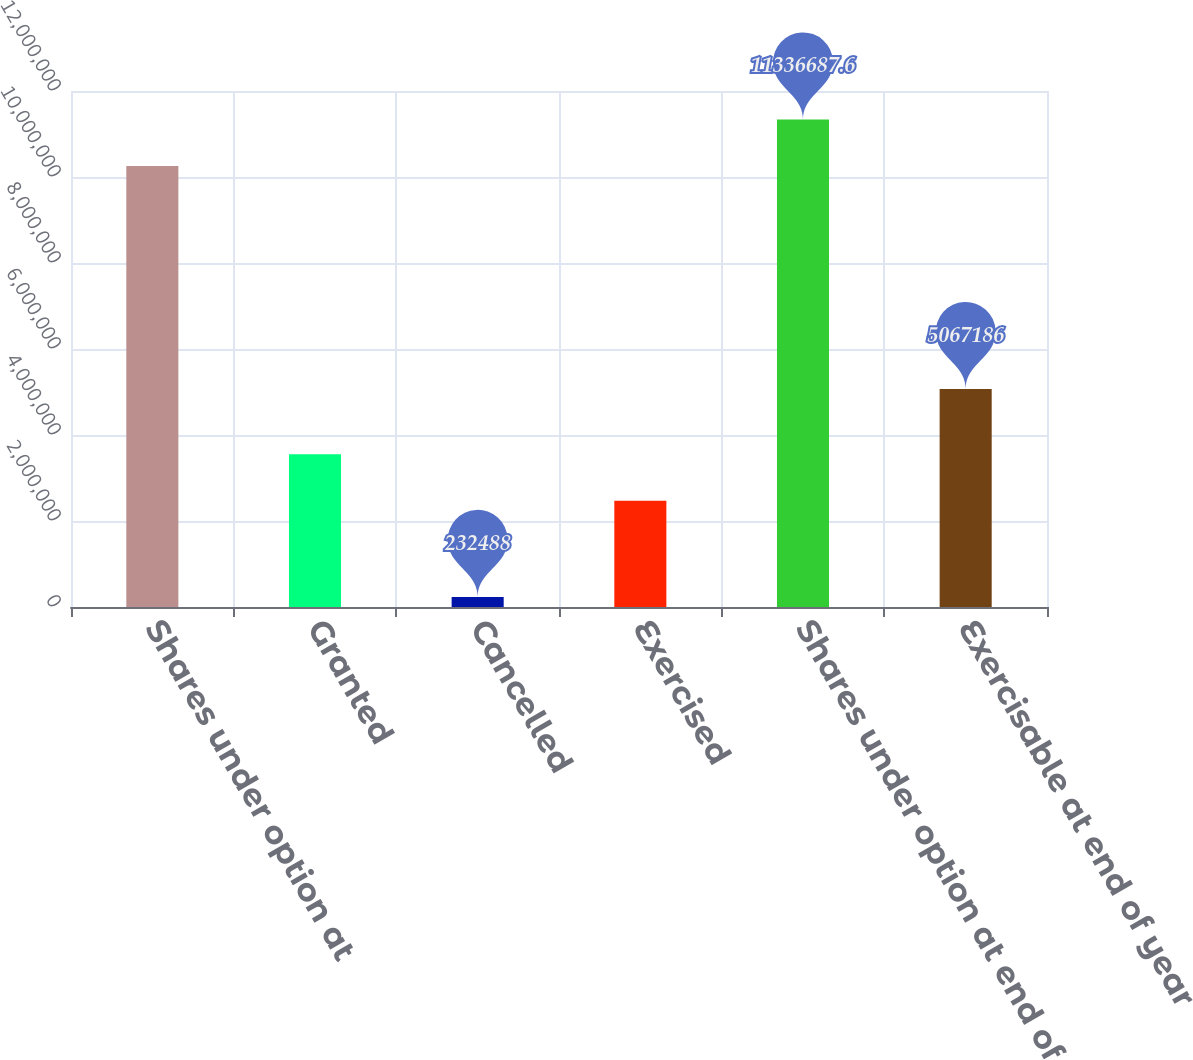<chart> <loc_0><loc_0><loc_500><loc_500><bar_chart><fcel>Shares under option at<fcel>Granted<fcel>Cancelled<fcel>Exercised<fcel>Shares under option at end of<fcel>Exercisable at end of year<nl><fcel>1.0256e+07<fcel>3.54994e+06<fcel>232488<fcel>2.46923e+06<fcel>1.13367e+07<fcel>5.06719e+06<nl></chart> 